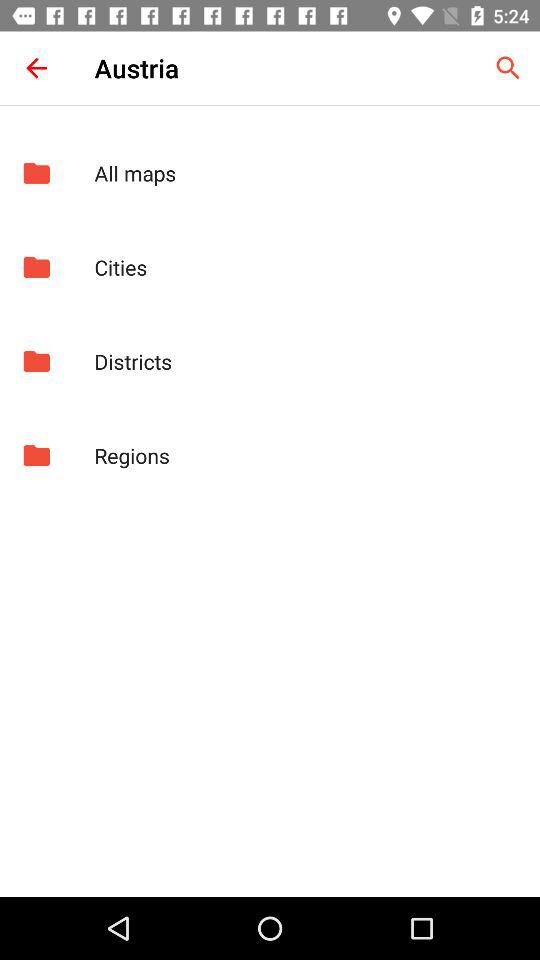How many maps of Austria are there?
When the provided information is insufficient, respond with <no answer>. <no answer> 